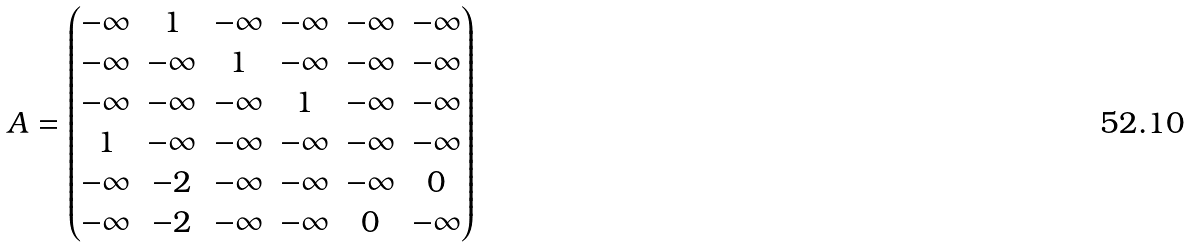Convert formula to latex. <formula><loc_0><loc_0><loc_500><loc_500>A = \begin{pmatrix} - \infty & 1 & - \infty & - \infty & - \infty & - \infty \\ - \infty & - \infty & 1 & - \infty & - \infty & - \infty \\ - \infty & - \infty & - \infty & 1 & - \infty & - \infty \\ 1 & - \infty & - \infty & - \infty & - \infty & - \infty \\ - \infty & - 2 & - \infty & - \infty & - \infty & 0 \\ - \infty & - 2 & - \infty & - \infty & 0 & - \infty \end{pmatrix}</formula> 